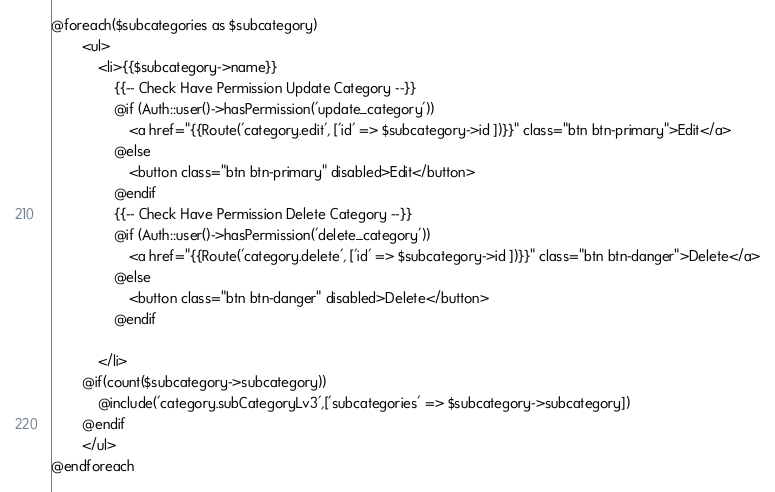Convert code to text. <code><loc_0><loc_0><loc_500><loc_500><_PHP_>
@foreach($subcategories as $subcategory)
        <ul>
            <li>{{$subcategory->name}}
            	{{-- Check Have Permission Update Category --}}
				@if (Auth::user()->hasPermission('update_category'))
	            	<a href="{{Route('category.edit', ['id' => $subcategory->id ])}}" class="btn btn-primary">Edit</a>
	            @else
                	<button class="btn btn-primary" disabled>Edit</button>
                @endif
	            {{-- Check Have Permission Delete Category --}}
			    @if (Auth::user()->hasPermission('delete_category'))
	            	<a href="{{Route('category.delete', ['id' => $subcategory->id ])}}" class="btn btn-danger">Delete</a>
	            @else
                	<button class="btn btn-danger" disabled>Delete</button>
                @endif

            </li>
	    @if(count($subcategory->subcategory))
            @include('category.subCategoryLv3',['subcategories' => $subcategory->subcategory])
        @endif
        </ul> 
@endforeach</code> 